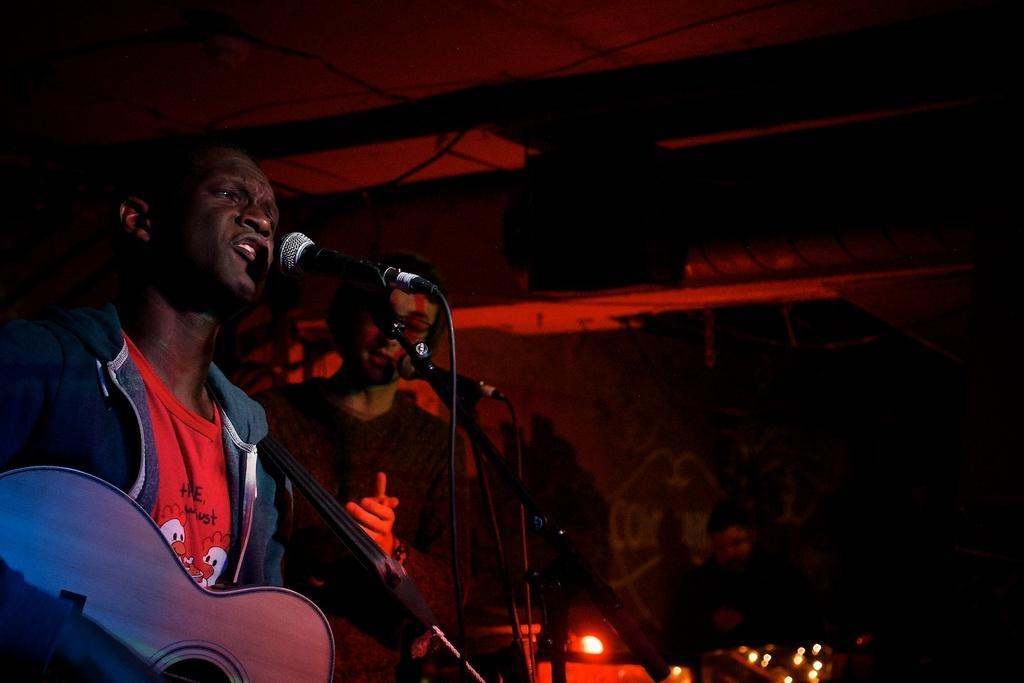Could you give a brief overview of what you see in this image? Here we can see a a person is singing and holding a guitar in his hands, and in front here is the microphone, and at side a person is standing. 